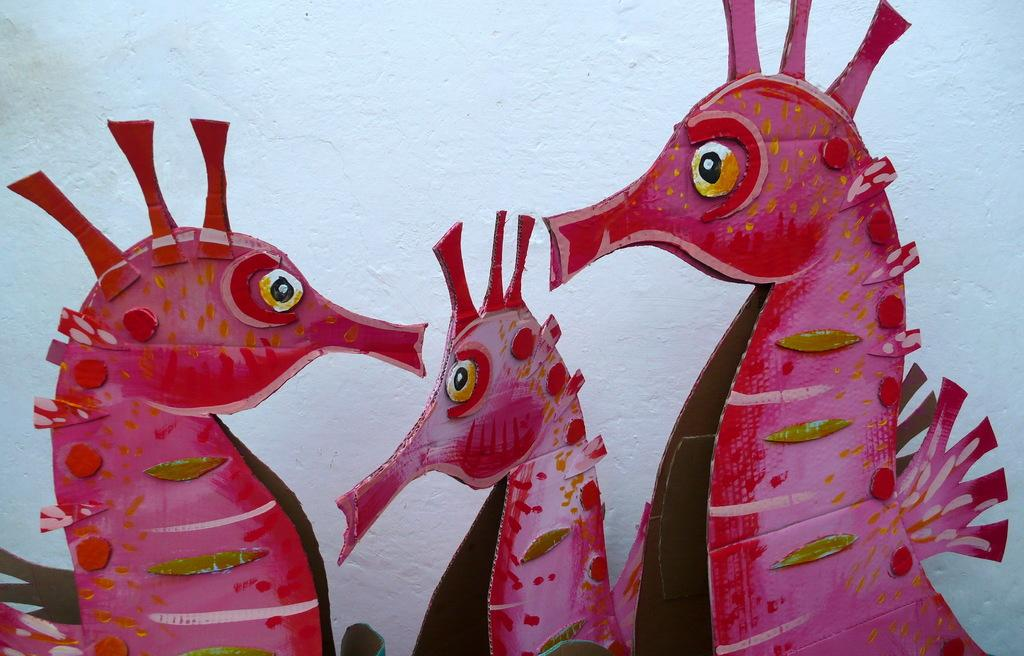What is the main feature of the image? There is a big white wall in the image. What is depicted on the wall? The wall has three red-colored northern seahorse pictures painted on it. What type of collar can be seen on the northern seahorses in the image? There are no collars present on the northern seahorses in the image, as they are painted pictures on a wall. 